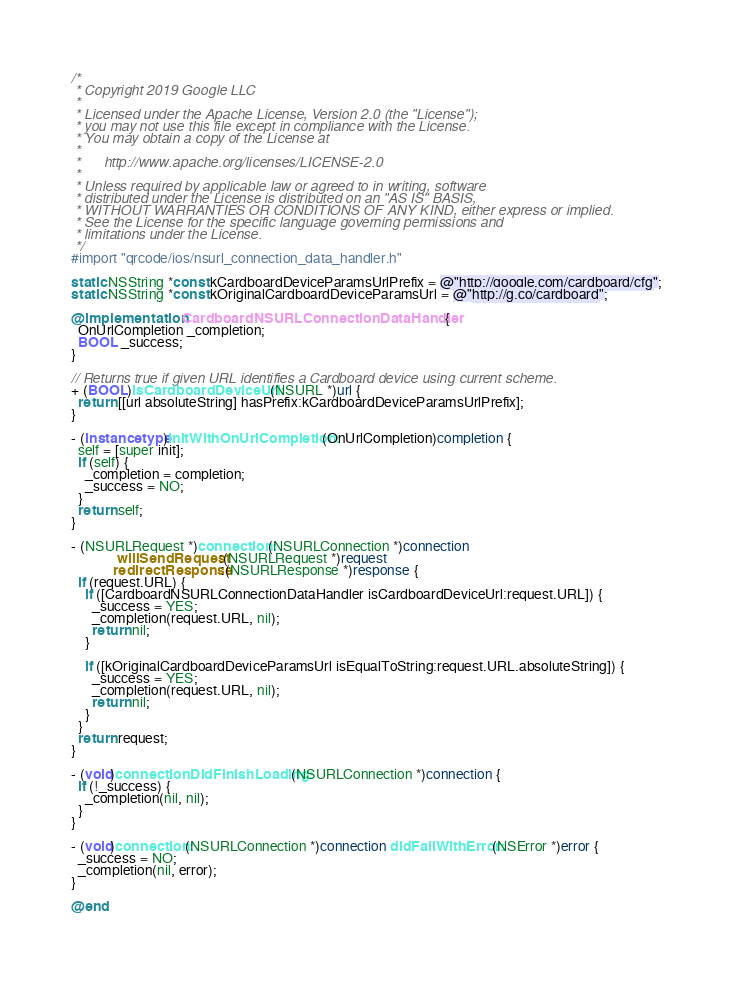<code> <loc_0><loc_0><loc_500><loc_500><_ObjectiveC_>/*
 * Copyright 2019 Google LLC
 *
 * Licensed under the Apache License, Version 2.0 (the "License");
 * you may not use this file except in compliance with the License.
 * You may obtain a copy of the License at
 *
 *      http://www.apache.org/licenses/LICENSE-2.0
 *
 * Unless required by applicable law or agreed to in writing, software
 * distributed under the License is distributed on an "AS IS" BASIS,
 * WITHOUT WARRANTIES OR CONDITIONS OF ANY KIND, either express or implied.
 * See the License for the specific language governing permissions and
 * limitations under the License.
 */
#import "qrcode/ios/nsurl_connection_data_handler.h"

static NSString *const kCardboardDeviceParamsUrlPrefix = @"http://google.com/cardboard/cfg";
static NSString *const kOriginalCardboardDeviceParamsUrl = @"http://g.co/cardboard";

@implementation CardboardNSURLConnectionDataHandler {
  OnUrlCompletion _completion;
  BOOL _success;
}

// Returns true if given URL identifies a Cardboard device using current scheme.
+ (BOOL)isCardboardDeviceUrl:(NSURL *)url {
  return [[url absoluteString] hasPrefix:kCardboardDeviceParamsUrlPrefix];
}

- (instancetype)initWithOnUrlCompletion:(OnUrlCompletion)completion {
  self = [super init];
  if (self) {
    _completion = completion;
    _success = NO;
  }
  return self;
}

- (NSURLRequest *)connection:(NSURLConnection *)connection
             willSendRequest:(NSURLRequest *)request
            redirectResponse:(NSURLResponse *)response {
  if (request.URL) {
    if ([CardboardNSURLConnectionDataHandler isCardboardDeviceUrl:request.URL]) {
      _success = YES;
      _completion(request.URL, nil);
      return nil;
    }

    if ([kOriginalCardboardDeviceParamsUrl isEqualToString:request.URL.absoluteString]) {
      _success = YES;
      _completion(request.URL, nil);
      return nil;
    }
  }
  return request;
}

- (void)connectionDidFinishLoading:(NSURLConnection *)connection {
  if (!_success) {
    _completion(nil, nil);
  }
}

- (void)connection:(NSURLConnection *)connection didFailWithError:(NSError *)error {
  _success = NO;
  _completion(nil, error);
}

@end
</code> 